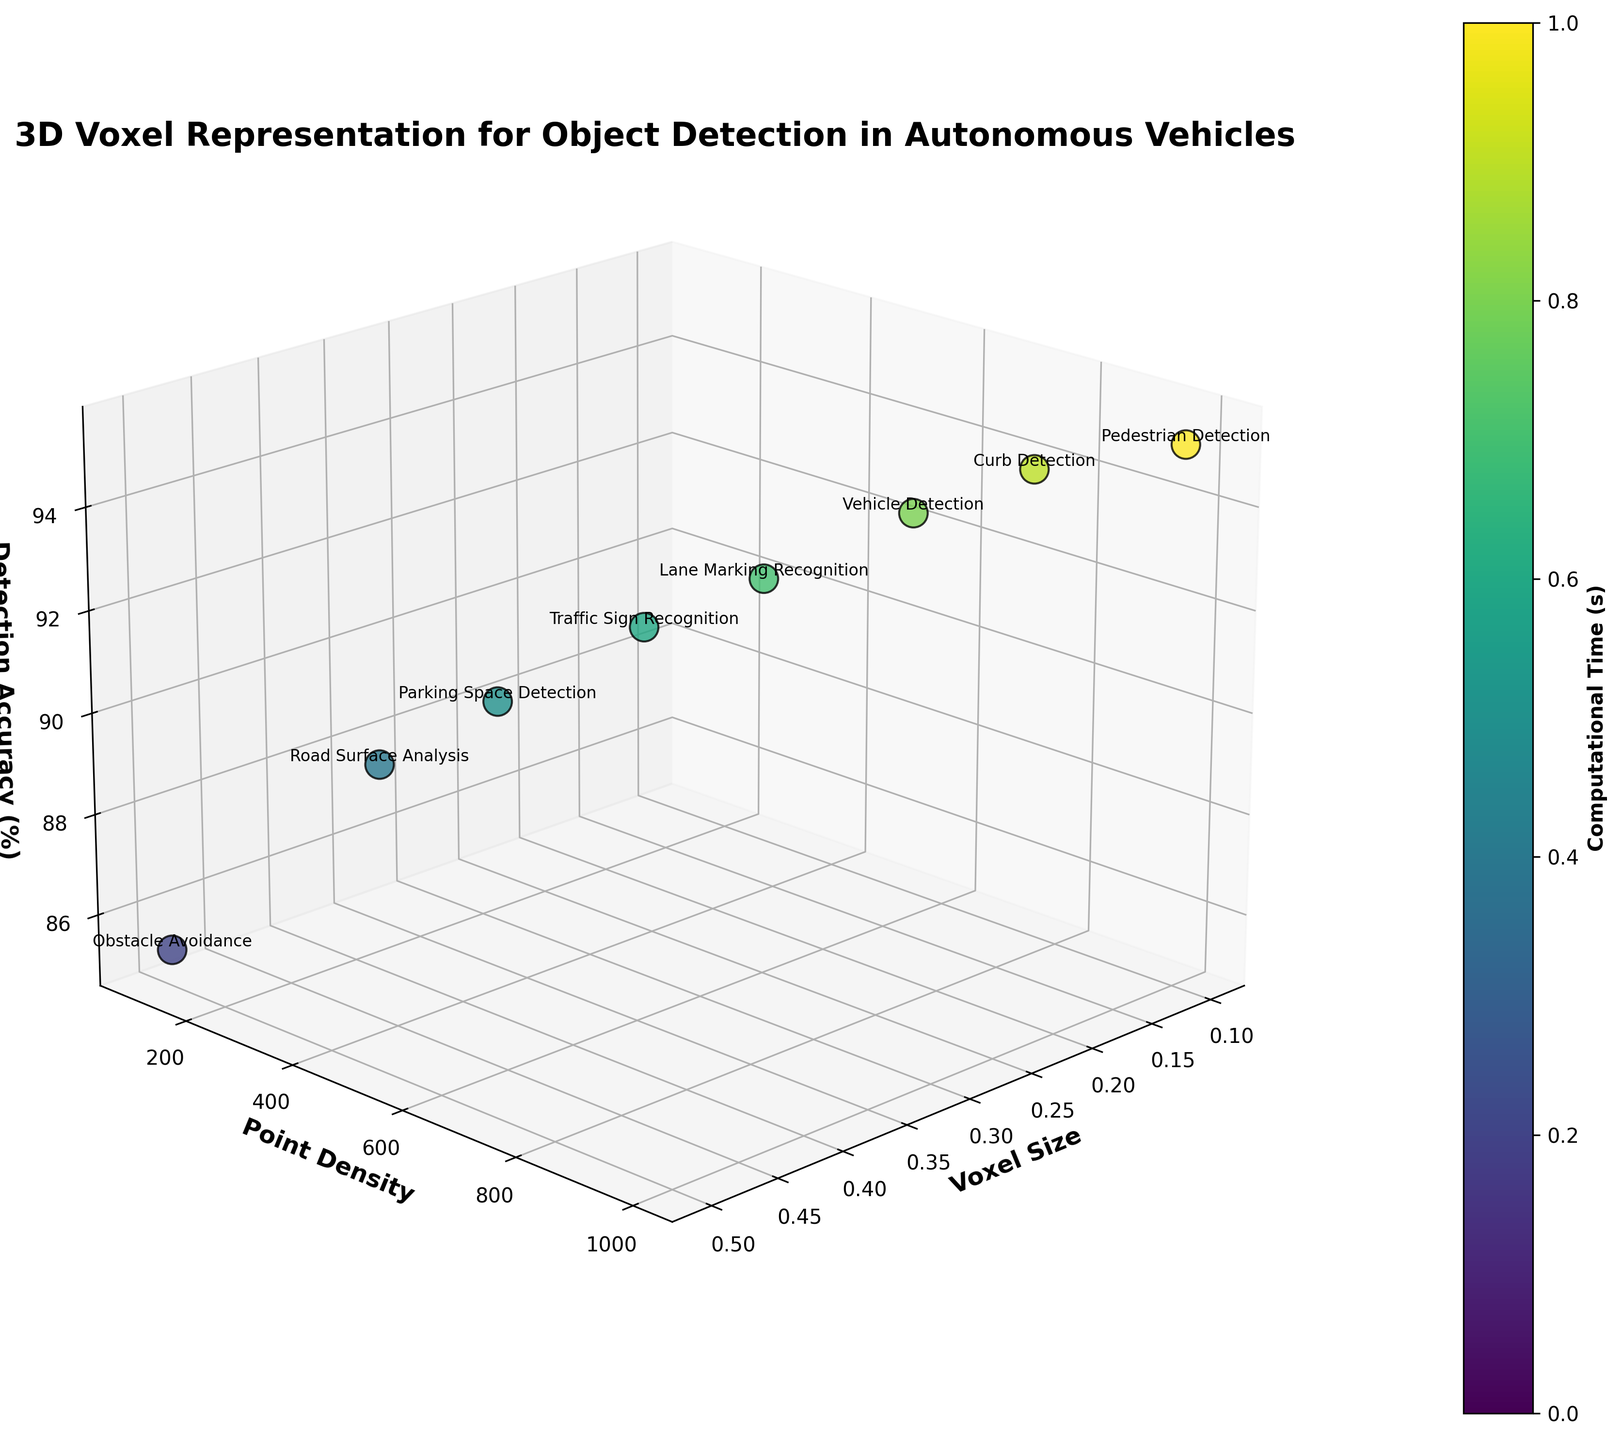How many applications are represented in the 3D plot? By analyzing the plot and counting the different labeled points corresponding to various applications, we find that there are eight distinct applications shown.
Answer: Eight Which application has the highest detection accuracy? By observing the z-axis values labeled "Detection Accuracy (%)", the "Pedestrian Detection" application has the highest accuracy at 95.2%.
Answer: Pedestrian Detection What's the relationship between Voxel Size and Point Density for Lane Marking Recognition? For "Lane Marking Recognition", locate its label on the chart. It corresponds to a Voxel Size of 0.25 and a Point Density of 600.
Answer: Voxel Size 0.25, Point Density 600 What application corresponds to the lowest point density? By checking the y-axis labeled "Point Density", the lowest density (100) is associated with "Obstacle Avoidance".
Answer: Obstacle Avoidance Compare the detection accuracy of Pedestrian Detection and Curb Detection. Which is higher and by how much? Pedestrian Detection has an accuracy of 95.2%, while Curb Detection has 94.6%. The difference is 0.6%.
Answer: Pedestrian Detection by 0.6% What is the trend between Voxel Size and Computational Time? Observing the color gradient corresponding to Computational Time, as Voxel Size increases, the colors lighten, indicating that Computational Time decreases.
Answer: Increasing Voxel Size decreases Computational Time What is the average detection accuracy of Road Surface Analysis and Traffic Sign Recognition? Road Surface Analysis has an accuracy of 88.7% and Traffic Sign Recognition has 91.5%. The average is (88.7 + 91.5) / 2 = 90.1%.
Answer: 90.1% How does the Point Density of Parking Space Detection compare to Curb Detection? Parking Space Detection has a Point Density of 350, while Curb Detection has 850. Curb Detection has a higher Point Density.
Answer: Curb Detection is higher Which applications have a Computational Time greater than 0.04 seconds? Checking the color bar legend for Computational Time (>0.04), we find that "Pedestrian Detection" and "Curb Detection" meet this criterion.
Answer: Pedestrian Detection and Curb Detection Is there any application that has a Voxel Size of 0.3? If so, what is its Detection Accuracy? "Traffic Sign Recognition" is located at Voxel Size 0.3 and has a Detection Accuracy of 91.5%.
Answer: Traffic Sign Recognition with 91.5% 